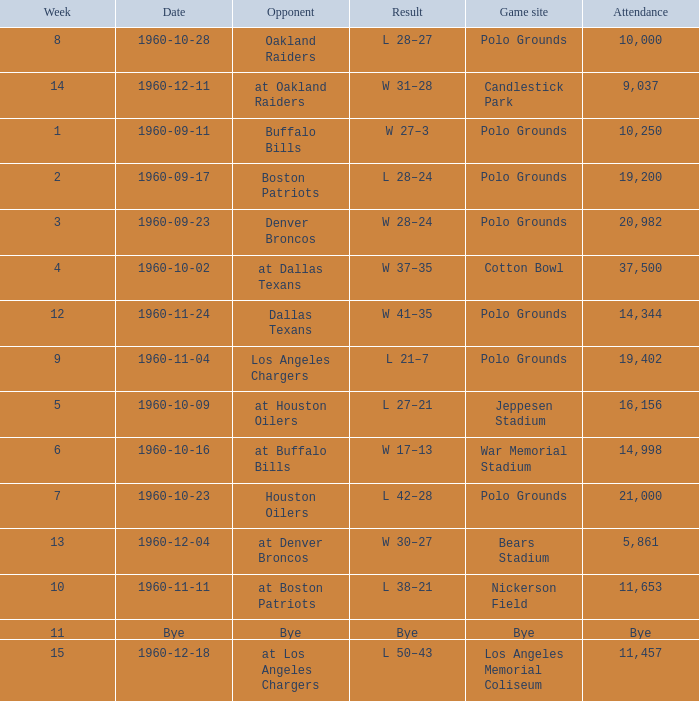What day had 37,500 attending? 1960-10-02. 